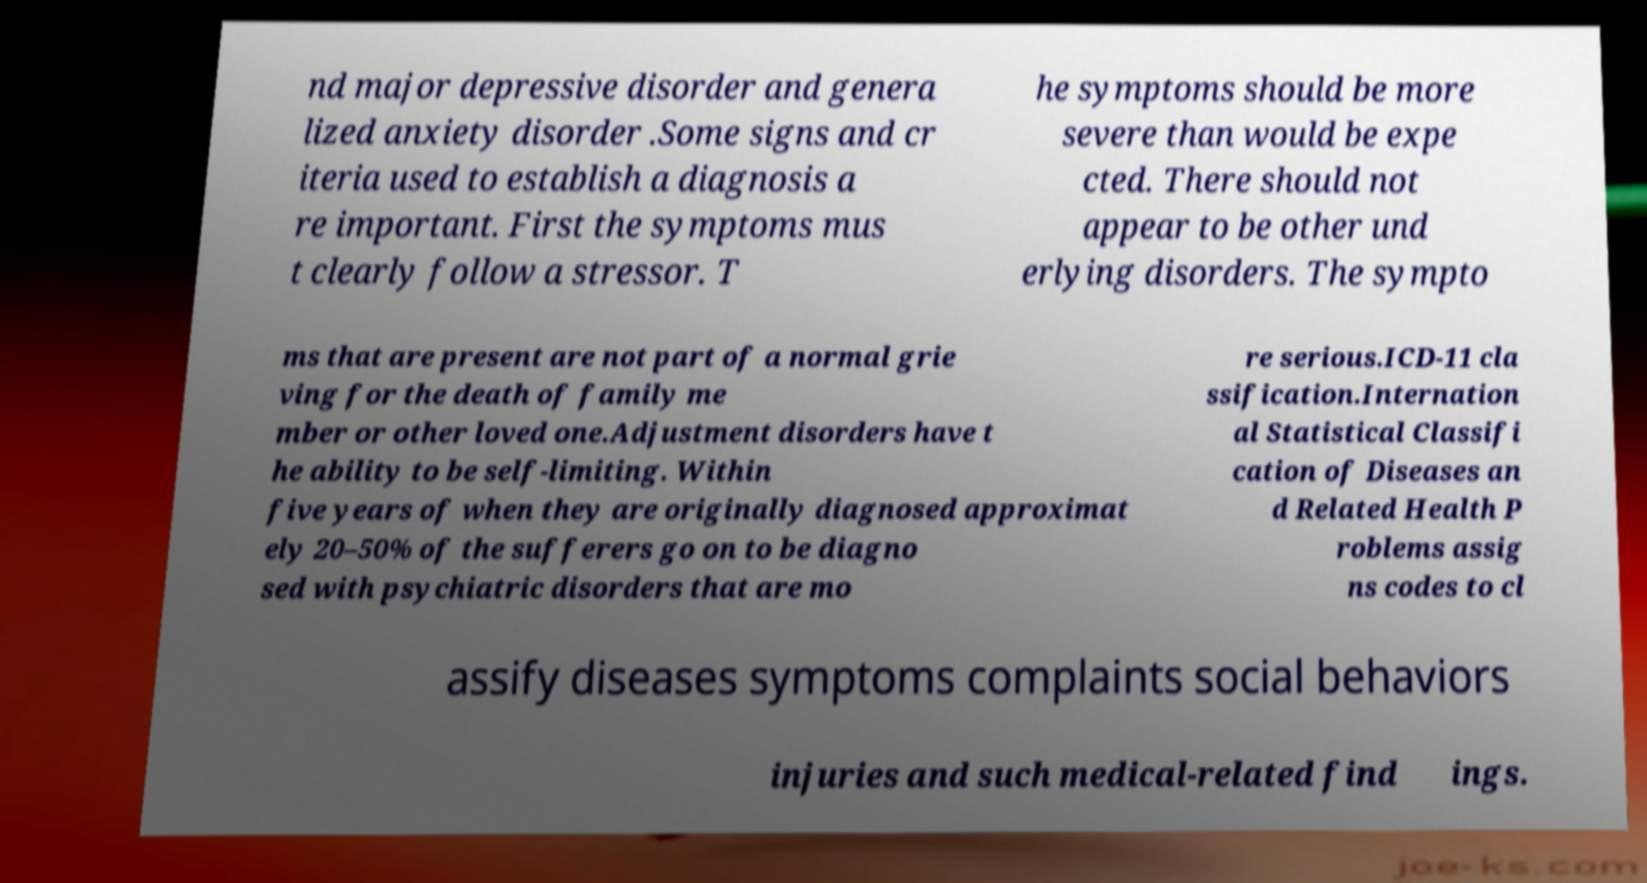Could you extract and type out the text from this image? nd major depressive disorder and genera lized anxiety disorder .Some signs and cr iteria used to establish a diagnosis a re important. First the symptoms mus t clearly follow a stressor. T he symptoms should be more severe than would be expe cted. There should not appear to be other und erlying disorders. The sympto ms that are present are not part of a normal grie ving for the death of family me mber or other loved one.Adjustment disorders have t he ability to be self-limiting. Within five years of when they are originally diagnosed approximat ely 20–50% of the sufferers go on to be diagno sed with psychiatric disorders that are mo re serious.ICD-11 cla ssification.Internation al Statistical Classifi cation of Diseases an d Related Health P roblems assig ns codes to cl assify diseases symptoms complaints social behaviors injuries and such medical-related find ings. 